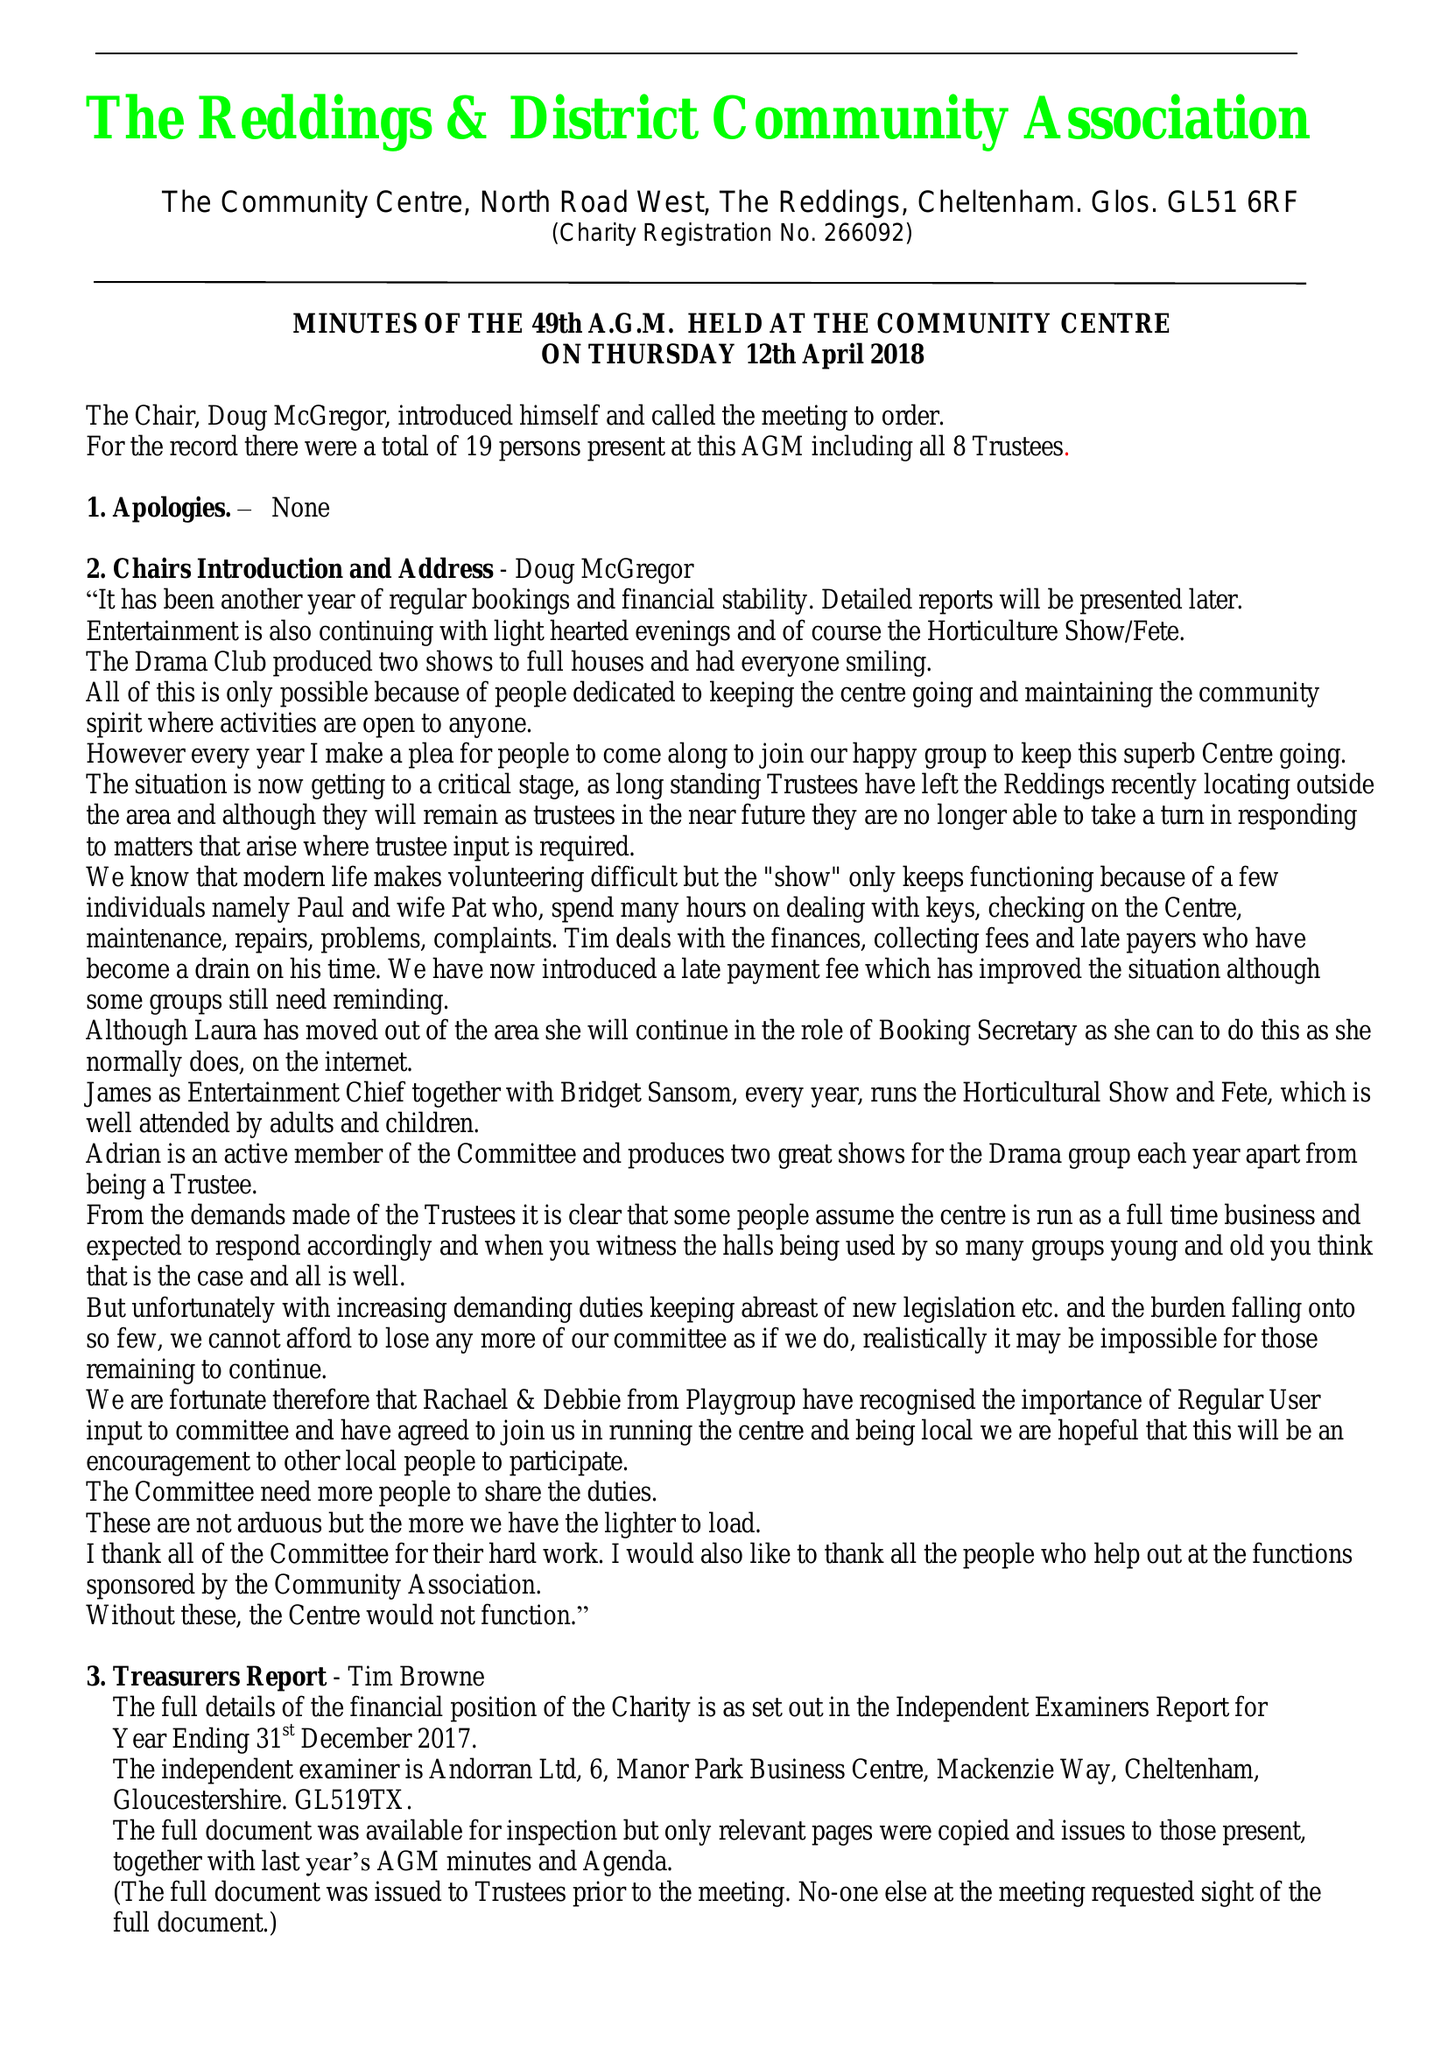What is the value for the spending_annually_in_british_pounds?
Answer the question using a single word or phrase. 18045.00 